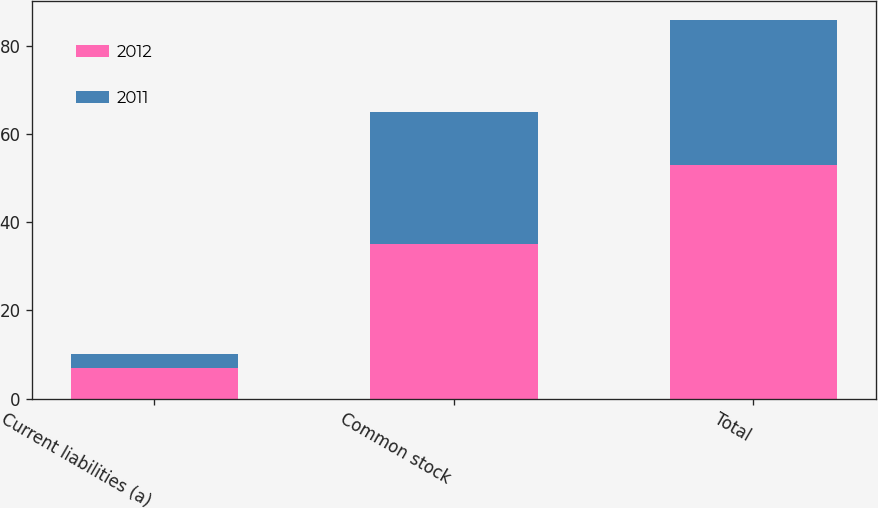<chart> <loc_0><loc_0><loc_500><loc_500><stacked_bar_chart><ecel><fcel>Current liabilities (a)<fcel>Common stock<fcel>Total<nl><fcel>2012<fcel>7<fcel>35<fcel>53<nl><fcel>2011<fcel>3<fcel>30<fcel>33<nl></chart> 